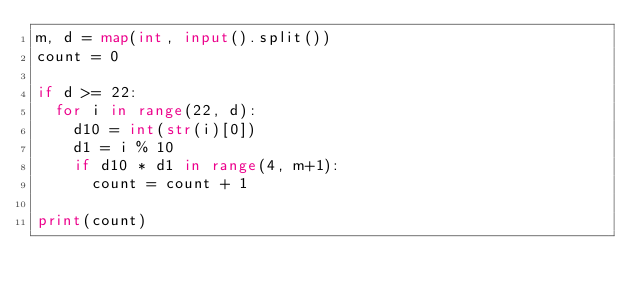Convert code to text. <code><loc_0><loc_0><loc_500><loc_500><_Python_>m, d = map(int, input().split())
count = 0

if d >= 22:
  for i in range(22, d):
    d10 = int(str(i)[0])
    d1 = i % 10
    if d10 * d1 in range(4, m+1):
      count = count + 1

print(count)
</code> 